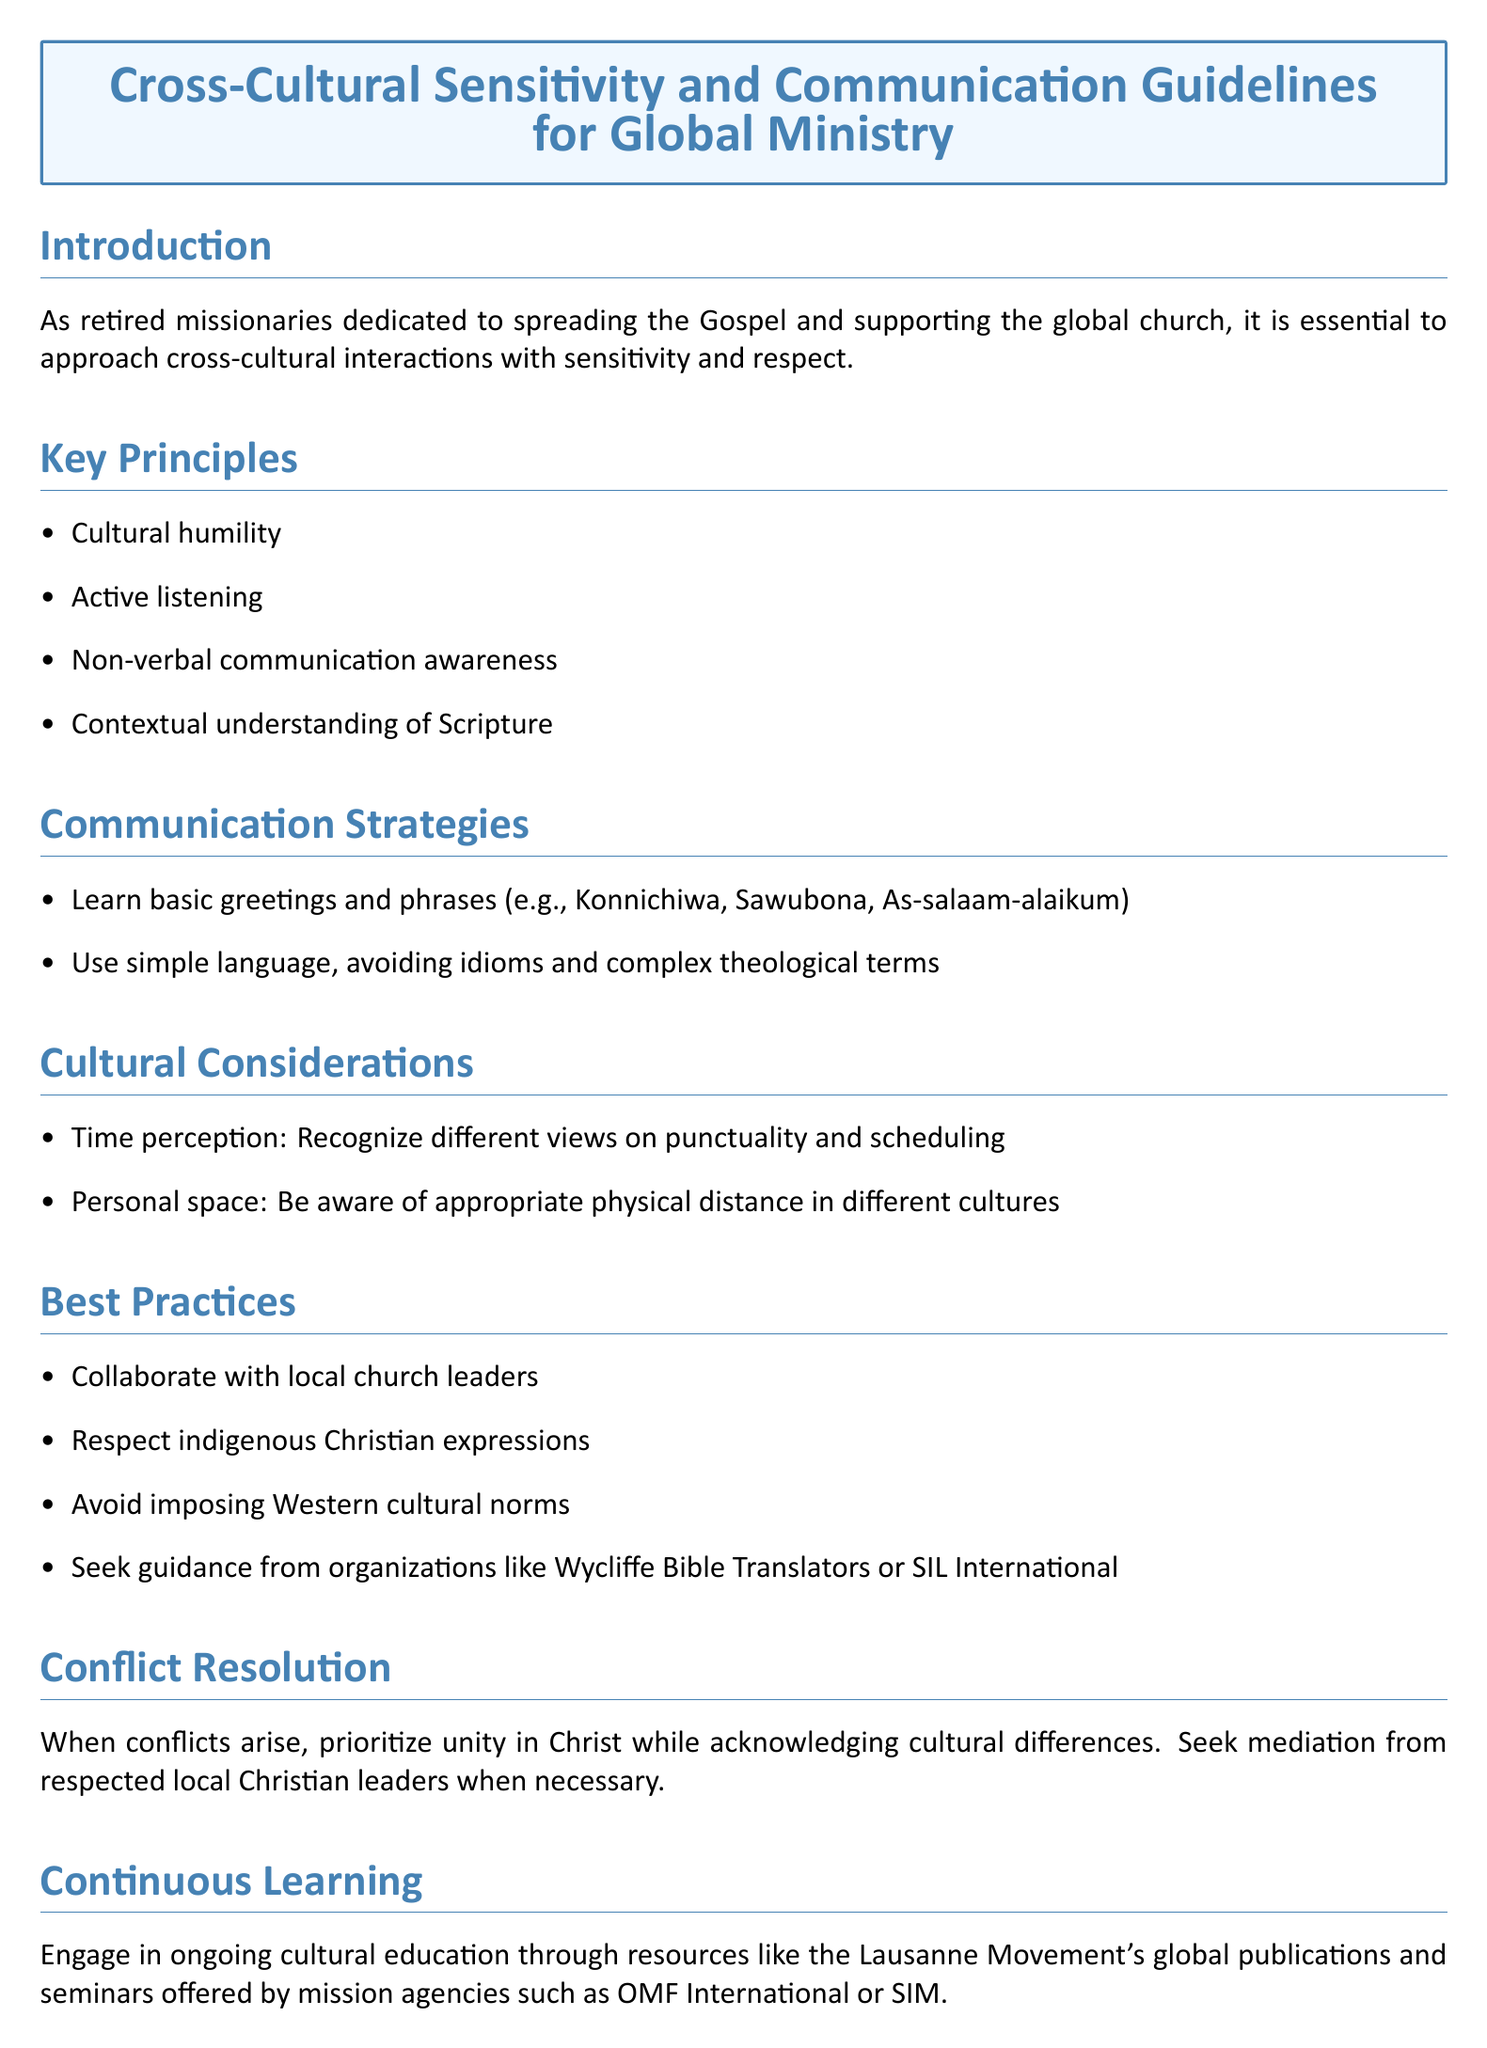what are the key principles listed in the document? The document states four key principles which are cultural humility, active listening, non-verbal communication awareness, and contextual understanding of Scripture.
Answer: cultural humility, active listening, non-verbal communication awareness, contextual understanding of Scripture what greeting phrase is suggested in the communication strategies? The document provides examples of basic greetings and phrases such as Konnichiwa, Sawubona, and As-salaam-alaikum.
Answer: Konnichiwa, Sawubona, As-salaam-alaikum what is one cultural consideration mentioned? The document lists cultural considerations including time perception and personal space. Time perception refers to recognizing different views on punctuality and scheduling.
Answer: time perception who should collaborate with local church leaders? The best practices suggest that retired missionaries and global church workers should collaborate with local church leaders.
Answer: local church leaders what is the purpose of conflict resolution in the document? The document states that when conflicts arise, the purpose is to prioritize unity in Christ while acknowledging cultural differences.
Answer: prioritize unity in Christ how should ongoing cultural education be pursued? The document advises engaging in ongoing cultural education through resources like the Lausanne Movement's global publications and mission agencies’ seminars.
Answer: Lausanne Movement's global publications, mission agencies’ seminars what organization is recommended for guidance in the best practices? The document recommends seeking guidance from organizations such as Wycliffe Bible Translators or SIL International.
Answer: Wycliffe Bible Translators, SIL International what is the main topic of the document? The document focuses on strategies and best practices for effectively engaging with diverse cultures while spreading the Gospel and supporting international churches.
Answer: Cross-Cultural Sensitivity and Communication Guidelines 